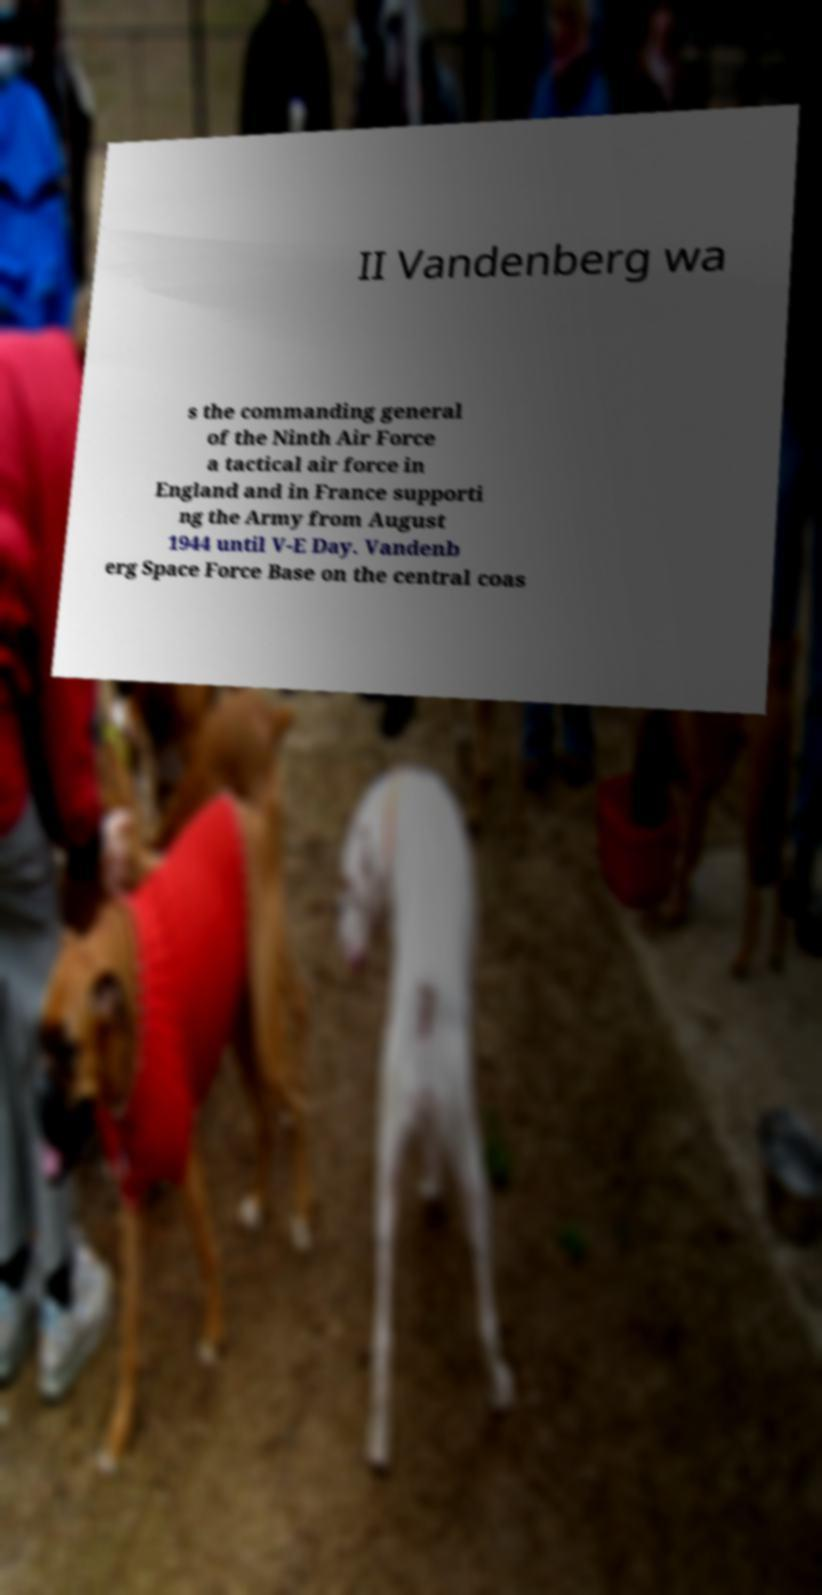For documentation purposes, I need the text within this image transcribed. Could you provide that? II Vandenberg wa s the commanding general of the Ninth Air Force a tactical air force in England and in France supporti ng the Army from August 1944 until V-E Day. Vandenb erg Space Force Base on the central coas 